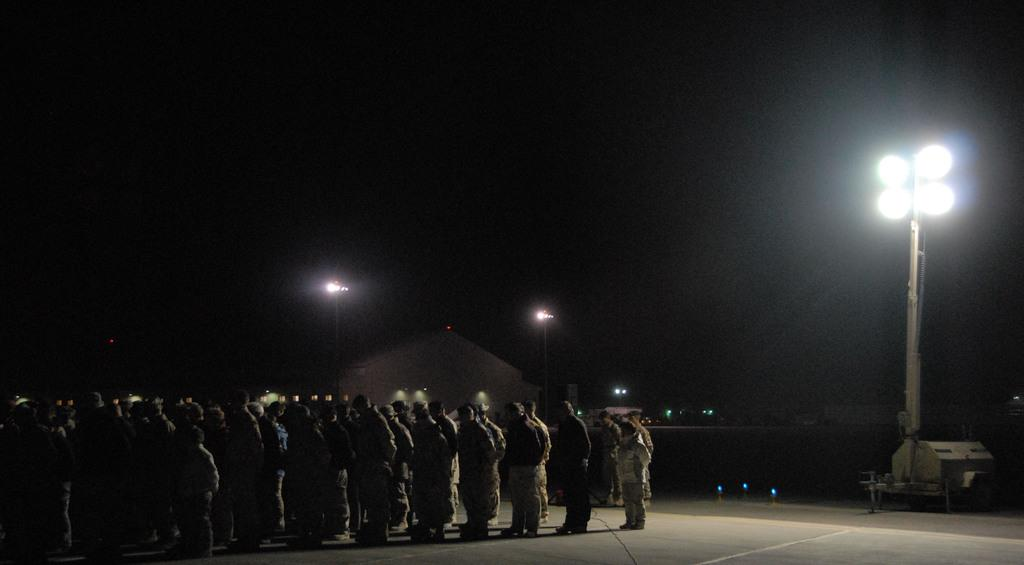What can be seen in the image? There is a group of people in the image. What are the people wearing? The people are wearing dresses. What is located to the right of the image? There are light poles to the right of the image. What type of structure is present in the image? There is a house in the image. What color is the background of the image? The background of the image is black. How many apples are on the window ledge in the image? There is no window ledge or apples present in the image. 